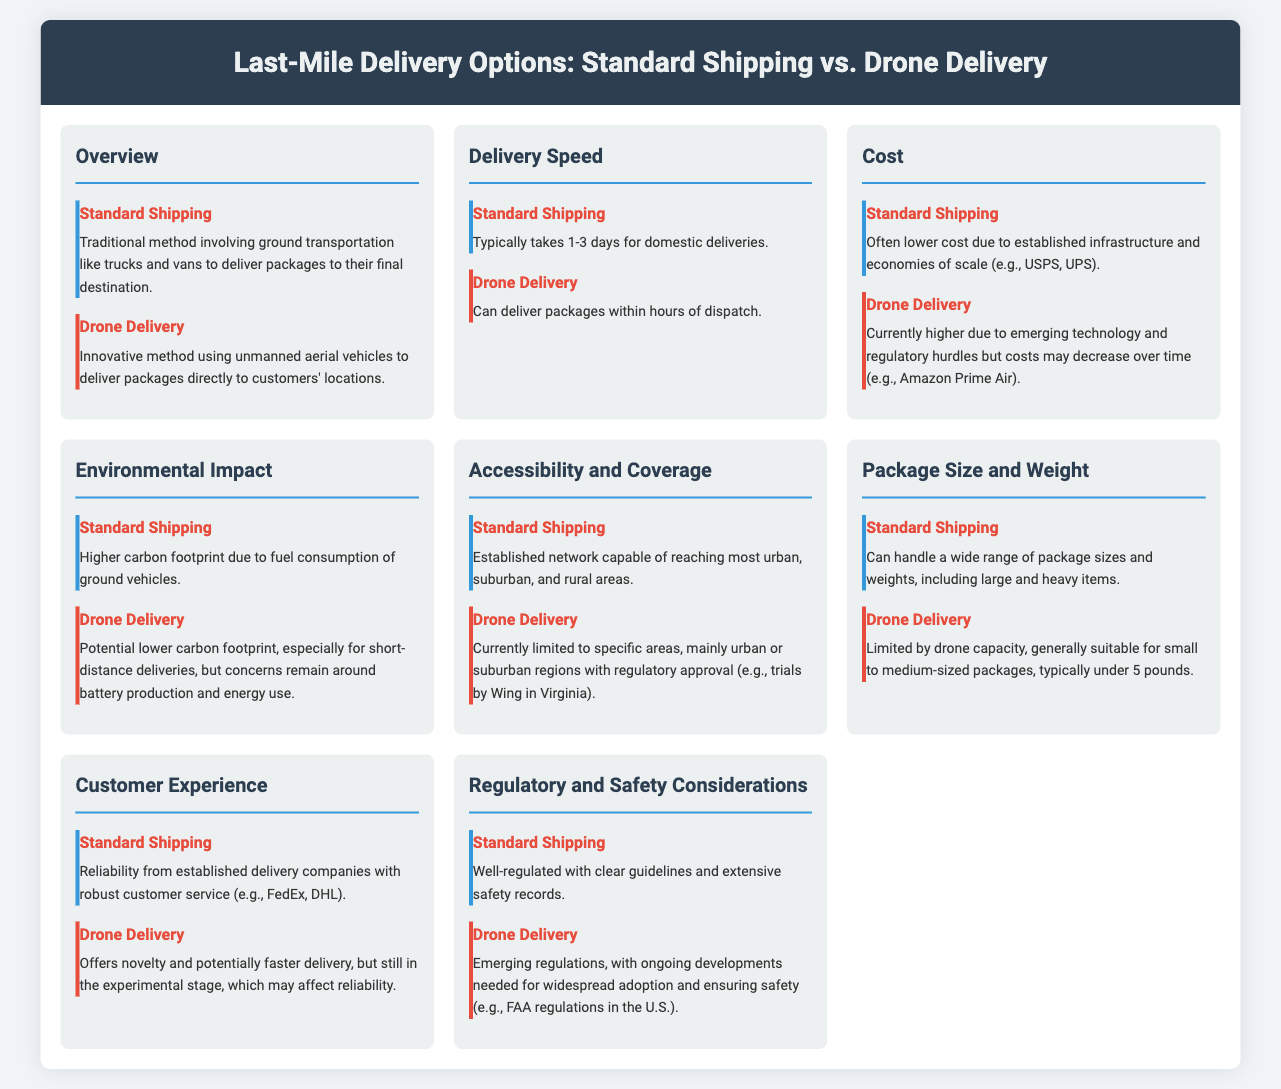What is the typical time for Standard Shipping? Standard Shipping typically takes 1-3 days for domestic deliveries as stated in the document.
Answer: 1-3 days What is the primary method used in Drone Delivery? The primary method used in Drone Delivery is unmanned aerial vehicles, as mentioned in the overview section.
Answer: Unmanned aerial vehicles Which delivery option generally has a lower cost? Standard Shipping often has lower costs due to established infrastructure and economies of scale, according to the cost section.
Answer: Standard Shipping What is the carbon footprint impact of Standard Shipping? Standard Shipping has a higher carbon footprint due to fuel consumption of ground vehicles, as discussed in the environmental impact section.
Answer: Higher carbon footprint What package weight does Drone Delivery typically handle? Drone Delivery is generally suitable for packages typically under 5 pounds, as indicated in the package size and weight section.
Answer: Under 5 pounds Which delivery option can deliver packages within hours? Drone Delivery can deliver packages within hours of dispatch, as stated in the delivery speed section.
Answer: Drone Delivery What is a key advantage of Standard Shipping in terms of coverage? Standard Shipping has an established network capable of reaching most urban, suburban, and rural areas, as mentioned in the accessibility and coverage section.
Answer: Established network What regulatory body is mentioned in relation to Drone Delivery? The FAA is mentioned regarding emerging regulations for Drone Delivery in the regulatory and safety considerations section.
Answer: FAA Which option offers potentially faster delivery? Drone Delivery offers potentially faster delivery, as highlighted in the customer experience section.
Answer: Drone Delivery 